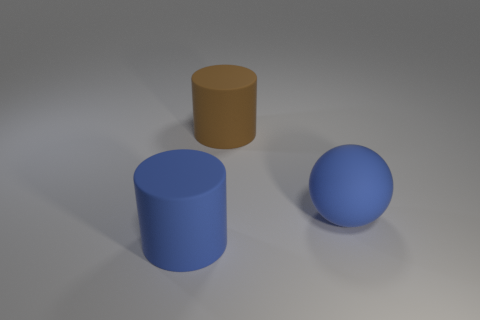Add 2 brown rubber things. How many objects exist? 5 Subtract all spheres. How many objects are left? 2 Add 3 balls. How many balls exist? 4 Subtract 1 blue cylinders. How many objects are left? 2 Subtract all brown rubber cylinders. Subtract all large brown things. How many objects are left? 1 Add 3 large brown rubber objects. How many large brown rubber objects are left? 4 